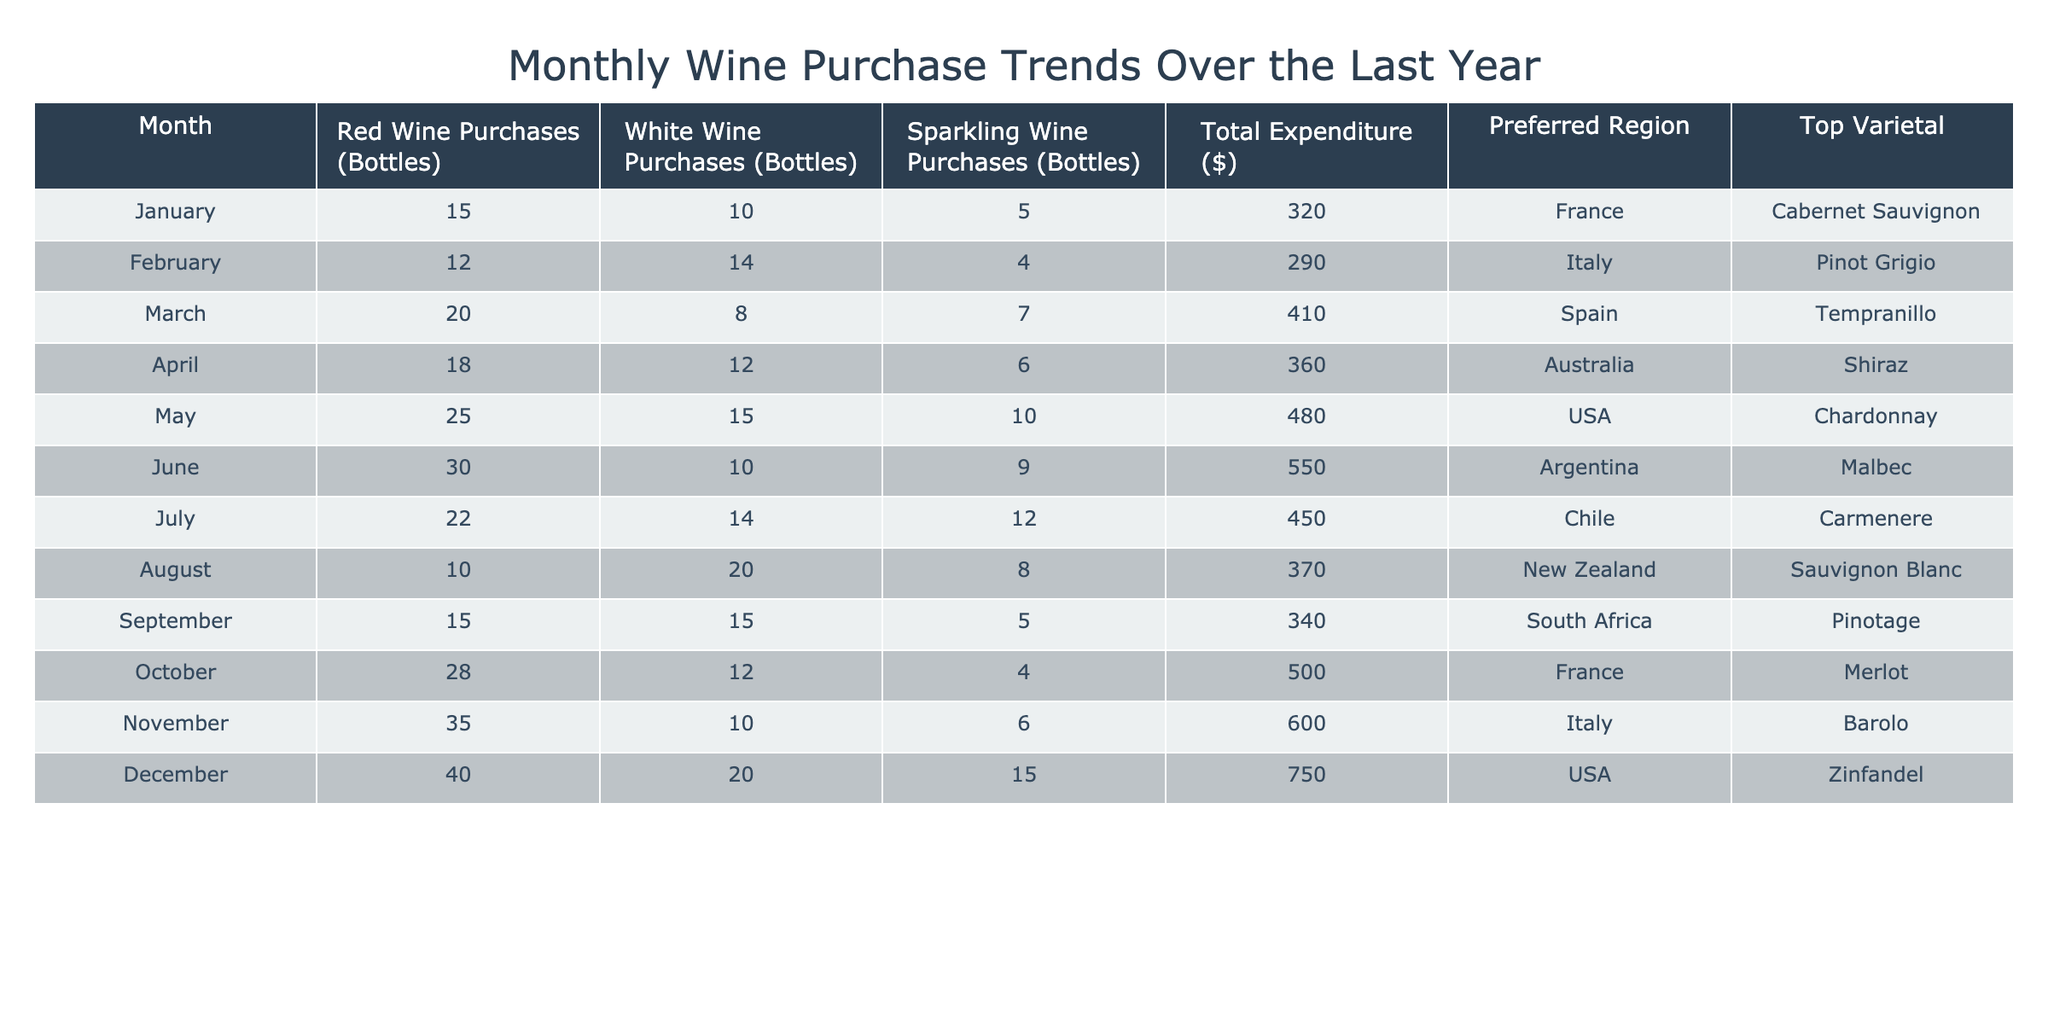What month had the highest total expenditure? The table indicates that December shows the highest total expenditure at $750, compared to all other months.
Answer: December Which wine type had the lowest purchases in January? In January, sparkling wine purchases were the lowest with 5 bottles, when compared to red (15) and white (10) wine purchases.
Answer: Sparkling wine What is the average number of red wine purchases over the last year? To find the average, sum the red wine purchases for all months (15 + 12 + 20 + 18 + 25 + 30 + 22 + 10 + 15 + 28 + 35 + 40 =  305) and divide by 12, resulting in 305 / 12 ≈ 25.42.
Answer: Approximately 25.42 Did the preferred region for September purchase a red wine varietal? Yes, in September, the preferred region was South Africa and the top varietal was Pinotage, which is a red wine.
Answer: Yes Which month saw the highest number of white wine purchases? August had the highest white wine purchases with 20 bottles, surpassing all other months.
Answer: August What is the difference in total expenditure between February and June? Subtract February’s total expenditure ($290) from June’s ($550). The difference is $550 - $290 = $260.
Answer: $260 Which varietal was most preferred in the month with the highest sparkling wine purchases? The month with the most sparkling wine purchases was December (15 bottles) and the top varietal was Zinfandel, though it wasn't sparkling. However, the varietal relevant to sparkling wine is not listed for highest purchases directly.
Answer: N/A (not applicable) How many Sparkling wine bottles were purchased in April? The table shows that in April, 6 bottles of sparkling wine were purchased, which is a specific fact found directly in the data.
Answer: 6 In which month did both red and white wine purchases exceed 20 bottles? March and December are the months where both red (20, 40) and white wine purchases (8, 20) exceeded 20 bottles.
Answer: March and December 